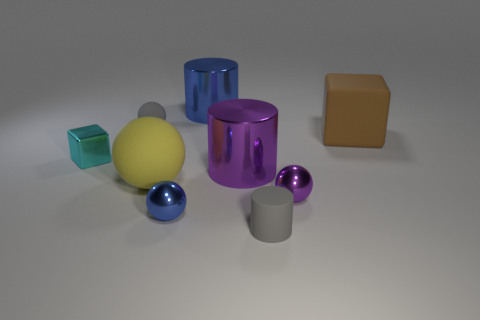What material is the cyan object? The cyan object appears to have a glossy finish and rigid form consistent with metal; its reflective surface and solid structure suggest it's likely a rendered representation of a metallic cylinder. 